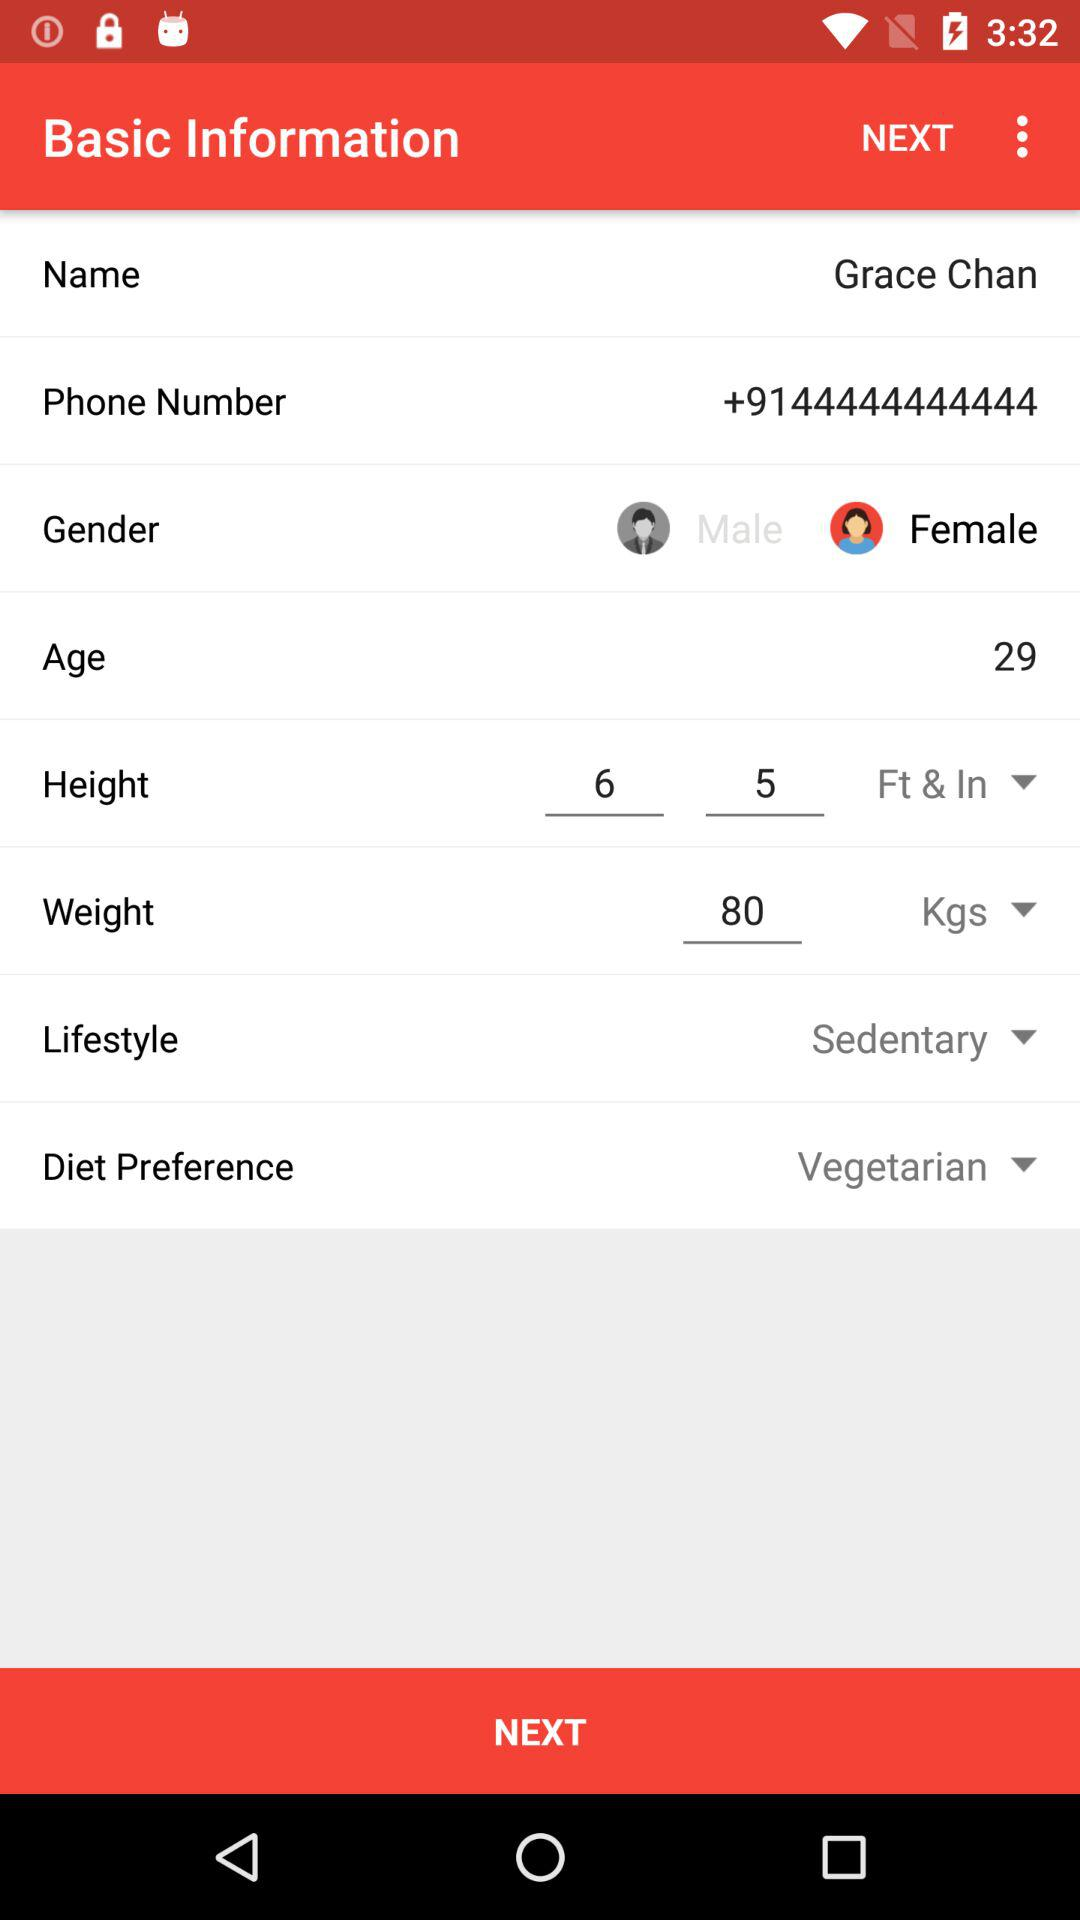Is Grace Chan a vegetarian or a non-vegetarian? Grace Chan is a vegetarian. 